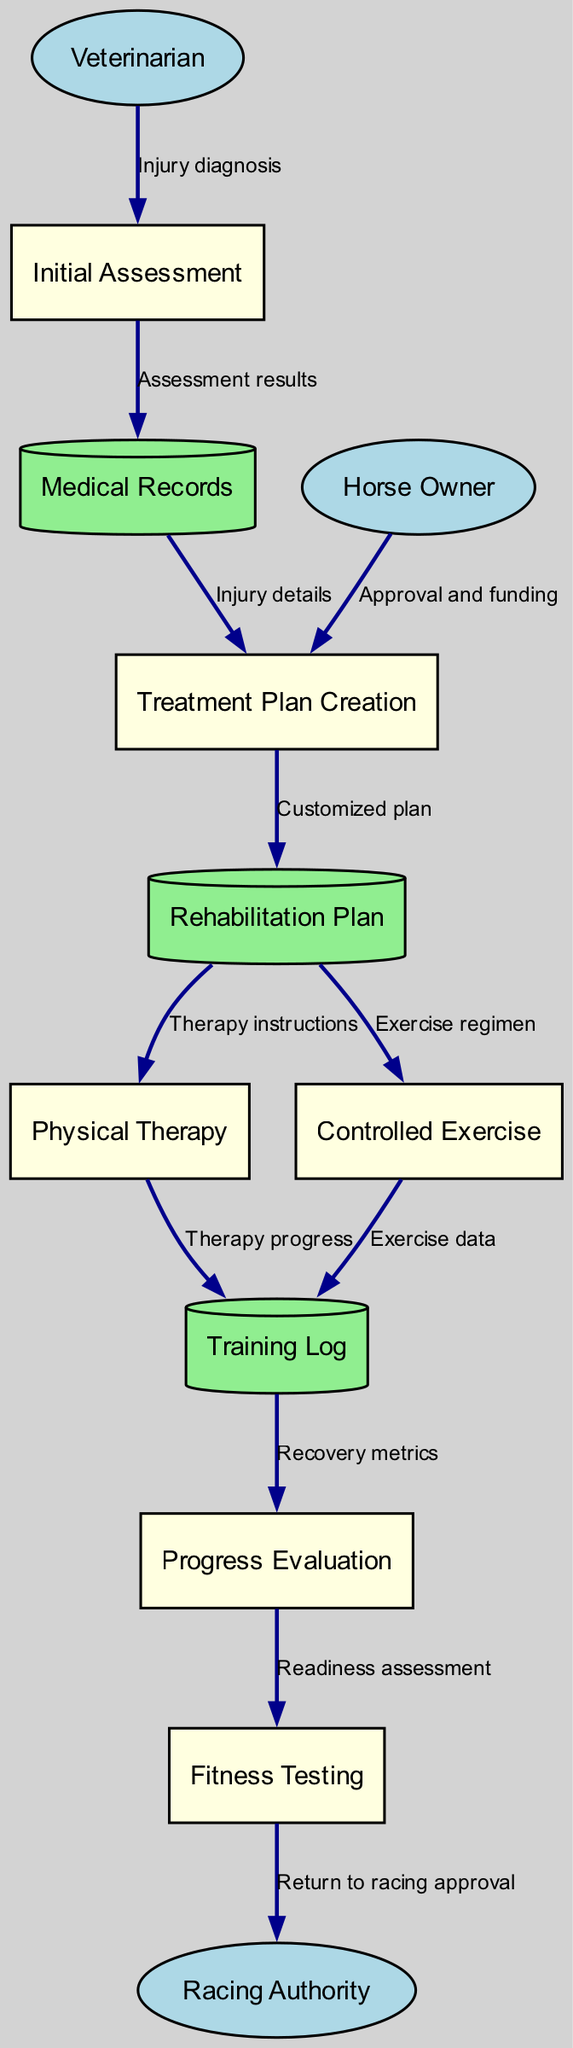What is the first process in the diagram? The diagram shows "Initial Assessment" as the first process, which is the starting point for the rehabilitation of the injured racehorse.
Answer: Initial Assessment How many external entities are present? The diagram lists three external entities: Veterinarian, Horse Owner, and Racing Authority. Therefore, the count is three.
Answer: 3 What flows into the "Treatment Plan Creation" process? The flow into the "Treatment Plan Creation" process comes from the "Medical Records" data store, which provides "Injury details" collected during initial assessment.
Answer: Medical Records Which process receives the "Readiness assessment"? The "Progress Evaluation" process is the one that sends out the "Readiness assessment" to the "Fitness Testing" process, indicating the horse's condition and readiness for the next stage.
Answer: Fitness Testing What data store is used during "Controlled Exercise"? The "Training Log" data store is utilized in the "Controlled Exercise" process to record and track the exercise data of the horse during the rehabilitation process.
Answer: Training Log What is the purpose of the flow from "Fitness Testing" to "Racing Authority"? The purpose of this flow is to communicate the "Return to racing approval," which indicates whether the horse is fit to resume racing after rehabilitation.
Answer: Return to racing approval What relationship exists between the "Horse Owner" and the "Treatment Plan Creation"? The flow from the "Horse Owner" to the "Treatment Plan Creation" process indicates that the owner provides "Approval and funding" essential for developing the treatment plan.
Answer: Approval and funding How many processes are involved in the rehabilitation flow? The diagram identifies six distinct processes in the overall rehabilitation flow for the injured racehorse, outlining each step from assessment to racing approval.
Answer: 6 Which data store is used for tracking therapy progress? The "Training Log" data store is where the progress of physical therapy is tracked and recorded, showcasing the therapies performed over time.
Answer: Training Log 